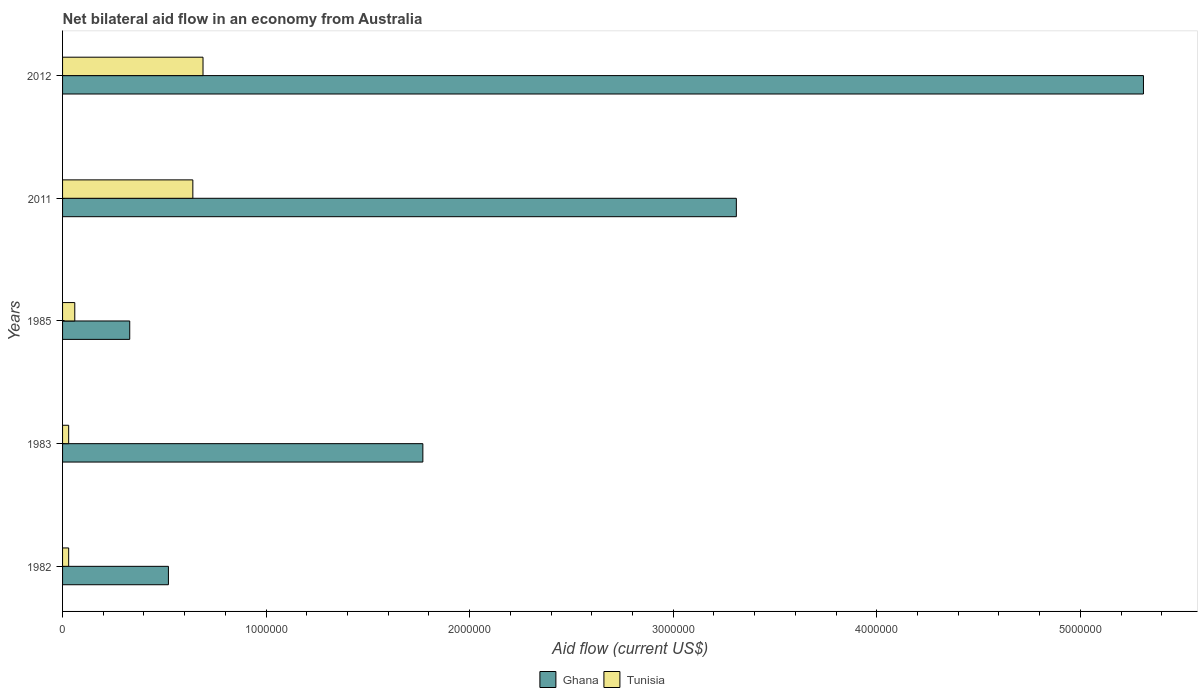Are the number of bars on each tick of the Y-axis equal?
Offer a terse response. Yes. How many bars are there on the 5th tick from the bottom?
Provide a succinct answer. 2. What is the label of the 4th group of bars from the top?
Make the answer very short. 1983. In how many cases, is the number of bars for a given year not equal to the number of legend labels?
Offer a very short reply. 0. Across all years, what is the maximum net bilateral aid flow in Ghana?
Keep it short and to the point. 5.31e+06. Across all years, what is the minimum net bilateral aid flow in Tunisia?
Make the answer very short. 3.00e+04. In which year was the net bilateral aid flow in Tunisia minimum?
Your response must be concise. 1982. What is the total net bilateral aid flow in Tunisia in the graph?
Make the answer very short. 1.45e+06. What is the difference between the net bilateral aid flow in Tunisia in 1983 and that in 2012?
Offer a terse response. -6.60e+05. What is the average net bilateral aid flow in Ghana per year?
Your answer should be compact. 2.25e+06. In the year 2012, what is the difference between the net bilateral aid flow in Ghana and net bilateral aid flow in Tunisia?
Your answer should be very brief. 4.62e+06. What is the ratio of the net bilateral aid flow in Tunisia in 1982 to that in 2012?
Your answer should be compact. 0.04. Is the difference between the net bilateral aid flow in Ghana in 1982 and 2012 greater than the difference between the net bilateral aid flow in Tunisia in 1982 and 2012?
Your answer should be compact. No. What is the difference between the highest and the lowest net bilateral aid flow in Tunisia?
Your response must be concise. 6.60e+05. In how many years, is the net bilateral aid flow in Tunisia greater than the average net bilateral aid flow in Tunisia taken over all years?
Provide a succinct answer. 2. Is the sum of the net bilateral aid flow in Ghana in 1983 and 2011 greater than the maximum net bilateral aid flow in Tunisia across all years?
Your answer should be compact. Yes. What does the 1st bar from the top in 2011 represents?
Provide a succinct answer. Tunisia. What does the 2nd bar from the bottom in 2011 represents?
Keep it short and to the point. Tunisia. Are all the bars in the graph horizontal?
Your answer should be very brief. Yes. Where does the legend appear in the graph?
Keep it short and to the point. Bottom center. How many legend labels are there?
Offer a very short reply. 2. How are the legend labels stacked?
Your answer should be very brief. Horizontal. What is the title of the graph?
Ensure brevity in your answer.  Net bilateral aid flow in an economy from Australia. What is the label or title of the Y-axis?
Offer a terse response. Years. What is the Aid flow (current US$) of Ghana in 1982?
Keep it short and to the point. 5.20e+05. What is the Aid flow (current US$) in Tunisia in 1982?
Make the answer very short. 3.00e+04. What is the Aid flow (current US$) in Ghana in 1983?
Provide a succinct answer. 1.77e+06. What is the Aid flow (current US$) in Ghana in 1985?
Offer a terse response. 3.30e+05. What is the Aid flow (current US$) in Ghana in 2011?
Provide a succinct answer. 3.31e+06. What is the Aid flow (current US$) in Tunisia in 2011?
Provide a short and direct response. 6.40e+05. What is the Aid flow (current US$) of Ghana in 2012?
Offer a terse response. 5.31e+06. What is the Aid flow (current US$) of Tunisia in 2012?
Keep it short and to the point. 6.90e+05. Across all years, what is the maximum Aid flow (current US$) in Ghana?
Provide a short and direct response. 5.31e+06. Across all years, what is the maximum Aid flow (current US$) of Tunisia?
Ensure brevity in your answer.  6.90e+05. Across all years, what is the minimum Aid flow (current US$) in Tunisia?
Provide a succinct answer. 3.00e+04. What is the total Aid flow (current US$) in Ghana in the graph?
Your answer should be compact. 1.12e+07. What is the total Aid flow (current US$) of Tunisia in the graph?
Give a very brief answer. 1.45e+06. What is the difference between the Aid flow (current US$) of Ghana in 1982 and that in 1983?
Your answer should be compact. -1.25e+06. What is the difference between the Aid flow (current US$) in Tunisia in 1982 and that in 1985?
Your answer should be very brief. -3.00e+04. What is the difference between the Aid flow (current US$) in Ghana in 1982 and that in 2011?
Offer a very short reply. -2.79e+06. What is the difference between the Aid flow (current US$) of Tunisia in 1982 and that in 2011?
Your answer should be very brief. -6.10e+05. What is the difference between the Aid flow (current US$) in Ghana in 1982 and that in 2012?
Your answer should be very brief. -4.79e+06. What is the difference between the Aid flow (current US$) of Tunisia in 1982 and that in 2012?
Your answer should be compact. -6.60e+05. What is the difference between the Aid flow (current US$) of Ghana in 1983 and that in 1985?
Give a very brief answer. 1.44e+06. What is the difference between the Aid flow (current US$) of Tunisia in 1983 and that in 1985?
Offer a terse response. -3.00e+04. What is the difference between the Aid flow (current US$) of Ghana in 1983 and that in 2011?
Provide a succinct answer. -1.54e+06. What is the difference between the Aid flow (current US$) in Tunisia in 1983 and that in 2011?
Provide a succinct answer. -6.10e+05. What is the difference between the Aid flow (current US$) of Ghana in 1983 and that in 2012?
Offer a terse response. -3.54e+06. What is the difference between the Aid flow (current US$) in Tunisia in 1983 and that in 2012?
Offer a terse response. -6.60e+05. What is the difference between the Aid flow (current US$) in Ghana in 1985 and that in 2011?
Provide a succinct answer. -2.98e+06. What is the difference between the Aid flow (current US$) in Tunisia in 1985 and that in 2011?
Ensure brevity in your answer.  -5.80e+05. What is the difference between the Aid flow (current US$) of Ghana in 1985 and that in 2012?
Give a very brief answer. -4.98e+06. What is the difference between the Aid flow (current US$) in Tunisia in 1985 and that in 2012?
Provide a short and direct response. -6.30e+05. What is the difference between the Aid flow (current US$) of Ghana in 2011 and that in 2012?
Your response must be concise. -2.00e+06. What is the difference between the Aid flow (current US$) in Tunisia in 2011 and that in 2012?
Offer a very short reply. -5.00e+04. What is the difference between the Aid flow (current US$) of Ghana in 1982 and the Aid flow (current US$) of Tunisia in 1983?
Make the answer very short. 4.90e+05. What is the difference between the Aid flow (current US$) in Ghana in 1982 and the Aid flow (current US$) in Tunisia in 1985?
Your response must be concise. 4.60e+05. What is the difference between the Aid flow (current US$) of Ghana in 1982 and the Aid flow (current US$) of Tunisia in 2011?
Make the answer very short. -1.20e+05. What is the difference between the Aid flow (current US$) in Ghana in 1982 and the Aid flow (current US$) in Tunisia in 2012?
Provide a succinct answer. -1.70e+05. What is the difference between the Aid flow (current US$) of Ghana in 1983 and the Aid flow (current US$) of Tunisia in 1985?
Give a very brief answer. 1.71e+06. What is the difference between the Aid flow (current US$) of Ghana in 1983 and the Aid flow (current US$) of Tunisia in 2011?
Provide a short and direct response. 1.13e+06. What is the difference between the Aid flow (current US$) in Ghana in 1983 and the Aid flow (current US$) in Tunisia in 2012?
Make the answer very short. 1.08e+06. What is the difference between the Aid flow (current US$) in Ghana in 1985 and the Aid flow (current US$) in Tunisia in 2011?
Provide a succinct answer. -3.10e+05. What is the difference between the Aid flow (current US$) of Ghana in 1985 and the Aid flow (current US$) of Tunisia in 2012?
Your answer should be compact. -3.60e+05. What is the difference between the Aid flow (current US$) in Ghana in 2011 and the Aid flow (current US$) in Tunisia in 2012?
Give a very brief answer. 2.62e+06. What is the average Aid flow (current US$) in Ghana per year?
Make the answer very short. 2.25e+06. In the year 1983, what is the difference between the Aid flow (current US$) in Ghana and Aid flow (current US$) in Tunisia?
Your response must be concise. 1.74e+06. In the year 2011, what is the difference between the Aid flow (current US$) of Ghana and Aid flow (current US$) of Tunisia?
Offer a terse response. 2.67e+06. In the year 2012, what is the difference between the Aid flow (current US$) of Ghana and Aid flow (current US$) of Tunisia?
Your answer should be compact. 4.62e+06. What is the ratio of the Aid flow (current US$) in Ghana in 1982 to that in 1983?
Your response must be concise. 0.29. What is the ratio of the Aid flow (current US$) of Ghana in 1982 to that in 1985?
Keep it short and to the point. 1.58. What is the ratio of the Aid flow (current US$) of Tunisia in 1982 to that in 1985?
Offer a terse response. 0.5. What is the ratio of the Aid flow (current US$) of Ghana in 1982 to that in 2011?
Give a very brief answer. 0.16. What is the ratio of the Aid flow (current US$) in Tunisia in 1982 to that in 2011?
Offer a very short reply. 0.05. What is the ratio of the Aid flow (current US$) in Ghana in 1982 to that in 2012?
Provide a succinct answer. 0.1. What is the ratio of the Aid flow (current US$) in Tunisia in 1982 to that in 2012?
Offer a terse response. 0.04. What is the ratio of the Aid flow (current US$) of Ghana in 1983 to that in 1985?
Provide a succinct answer. 5.36. What is the ratio of the Aid flow (current US$) in Ghana in 1983 to that in 2011?
Offer a terse response. 0.53. What is the ratio of the Aid flow (current US$) in Tunisia in 1983 to that in 2011?
Your answer should be compact. 0.05. What is the ratio of the Aid flow (current US$) in Tunisia in 1983 to that in 2012?
Provide a succinct answer. 0.04. What is the ratio of the Aid flow (current US$) of Ghana in 1985 to that in 2011?
Offer a terse response. 0.1. What is the ratio of the Aid flow (current US$) of Tunisia in 1985 to that in 2011?
Offer a terse response. 0.09. What is the ratio of the Aid flow (current US$) in Ghana in 1985 to that in 2012?
Your answer should be very brief. 0.06. What is the ratio of the Aid flow (current US$) of Tunisia in 1985 to that in 2012?
Ensure brevity in your answer.  0.09. What is the ratio of the Aid flow (current US$) in Ghana in 2011 to that in 2012?
Keep it short and to the point. 0.62. What is the ratio of the Aid flow (current US$) of Tunisia in 2011 to that in 2012?
Ensure brevity in your answer.  0.93. What is the difference between the highest and the second highest Aid flow (current US$) in Ghana?
Keep it short and to the point. 2.00e+06. What is the difference between the highest and the second highest Aid flow (current US$) in Tunisia?
Provide a succinct answer. 5.00e+04. What is the difference between the highest and the lowest Aid flow (current US$) in Ghana?
Your answer should be very brief. 4.98e+06. What is the difference between the highest and the lowest Aid flow (current US$) in Tunisia?
Give a very brief answer. 6.60e+05. 